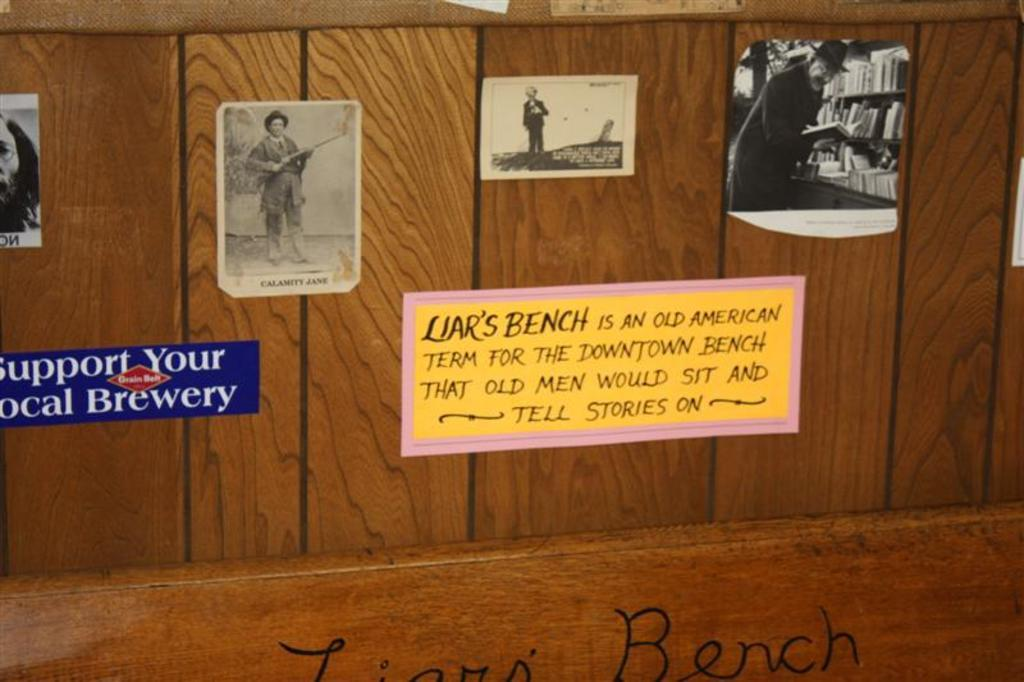<image>
Relay a brief, clear account of the picture shown. Pictures and a description on the old Liar's Bench which was were old men would sit and tell stories. 